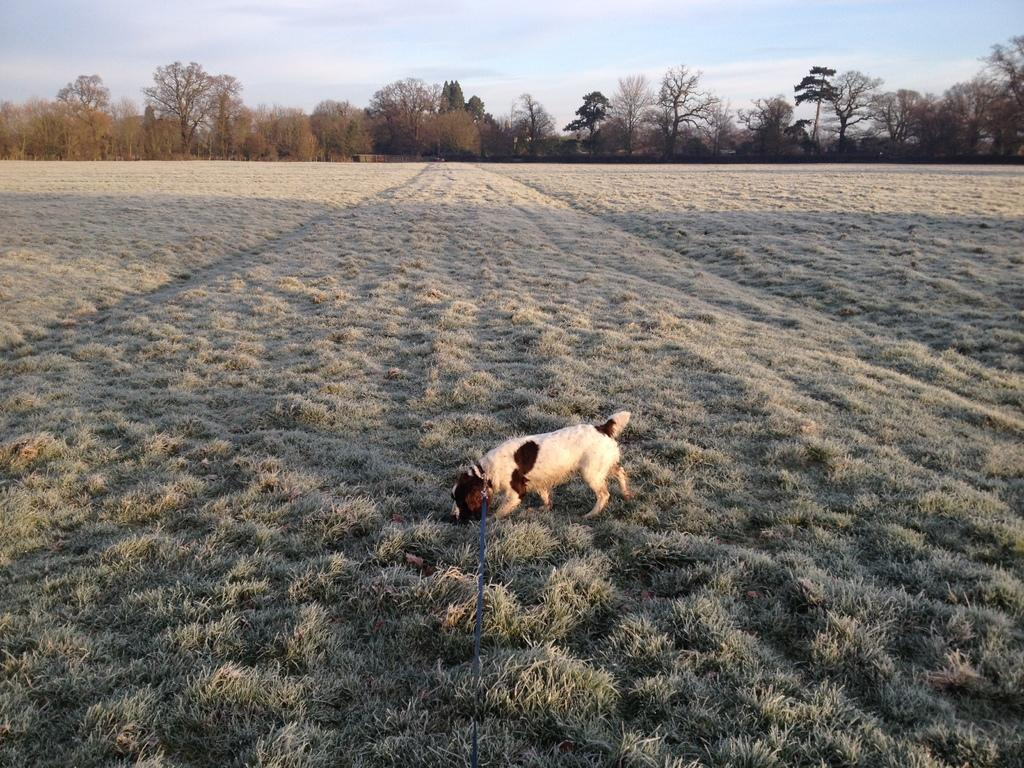What type of animal is in the image? There is a dog in the image. Where is the dog located? The dog is on the ground. What is the dog wearing? The dog has a belt on it. What can be seen in the background of the image? There is grass, trees, and the sky visible in the background of the image. What type of discussion is taking place between the dog and the guitar in the image? There is no guitar present in the image, and therefore no discussion can be observed between the dog and a guitar. 